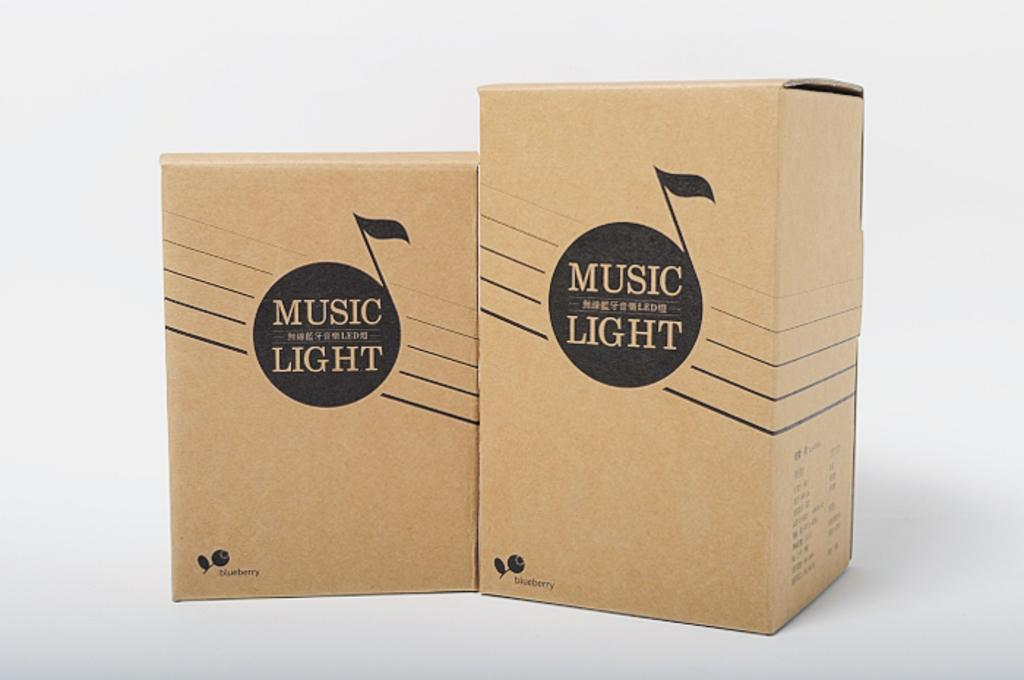How many cardboard boxes are in the image? There are two cardboard boxes in the image. What colors are the boxes? One box is black in color, and the other box is brown in color. Where are the boxes placed? The boxes are on a white colored surface. What is the color of the background in the image? The background of the image is white. What type of beast can be seen roaming in the background of the image? There is no beast present in the image; the background is white. 